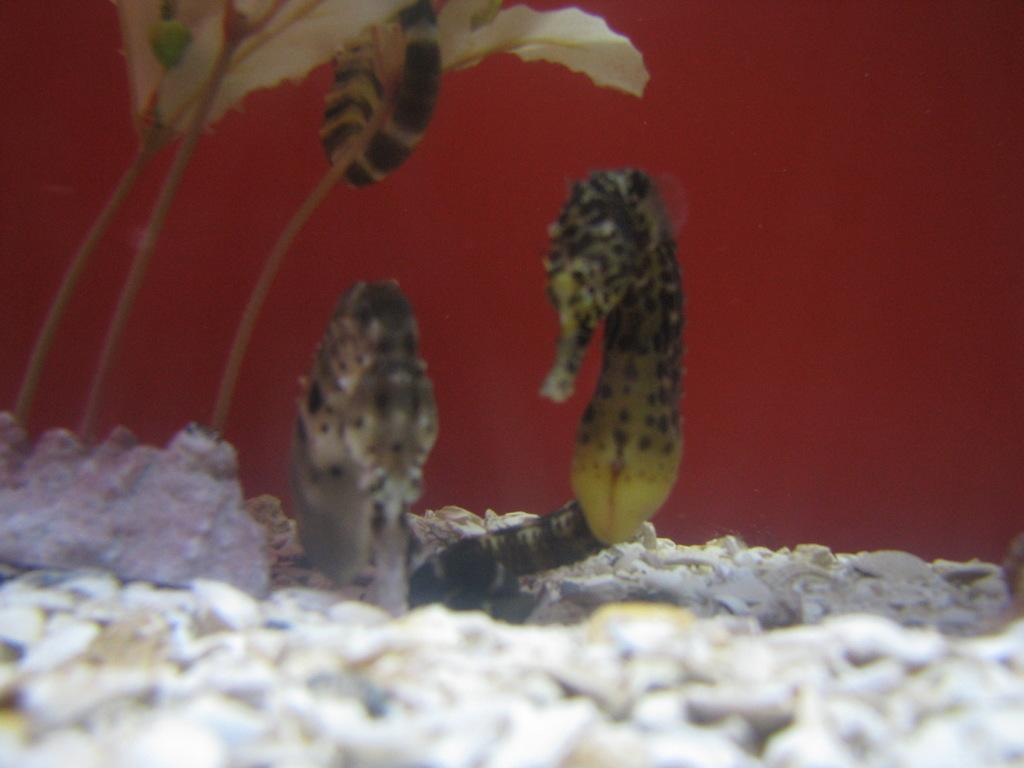What type of marine animals are in the image? There are seahorses in the image. What can be seen on the left side of the image? There is a flower on the left side of the image. What is present at the bottom of the image? There are stones at the bottom of the image. What type of potato is being used as a sofa in the image? There is no potato or sofa present in the image; it features seahorses, a flower, and stones. 